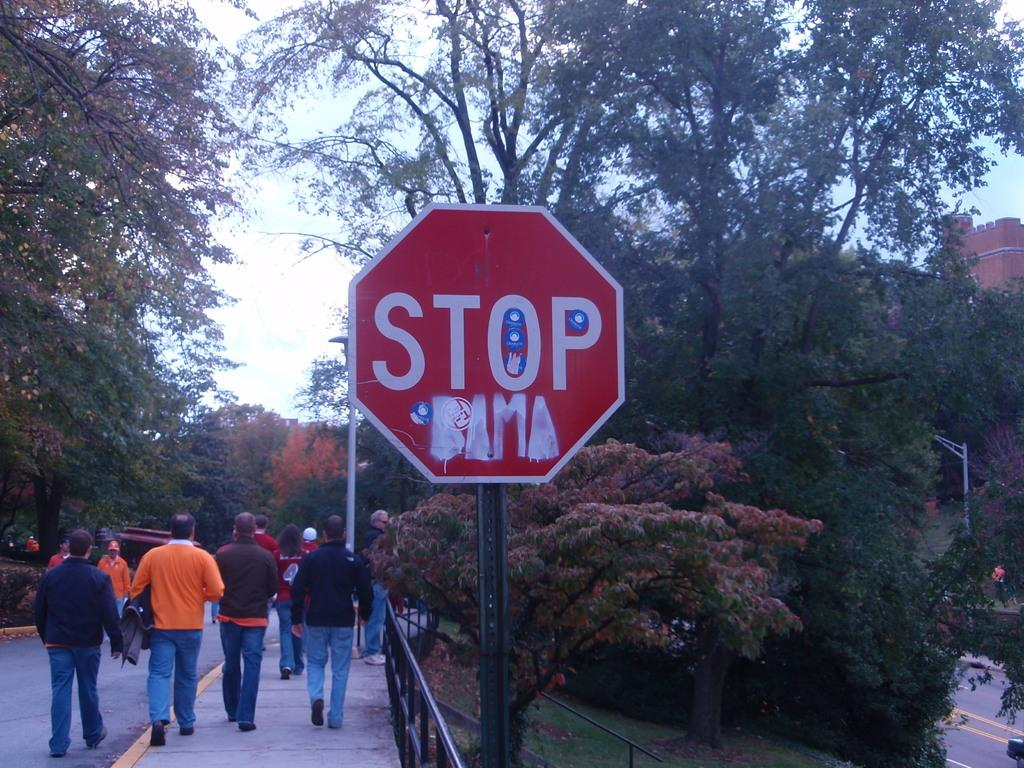What is located in the middle of the image? There is a sign board in the middle of the image. What can be seen on the left side of the image? There is a road on the left side of the image. What are the people in the image doing? There are people walking on the road. What is visible in the background of the image? There are trees in the background of the image. How many roses can be seen on the sign board in the image? There are no roses present on the sign board in the image. What advice does the mom give to the people walking on the road in the image? There is no mom present in the image, and therefore no advice can be given. 